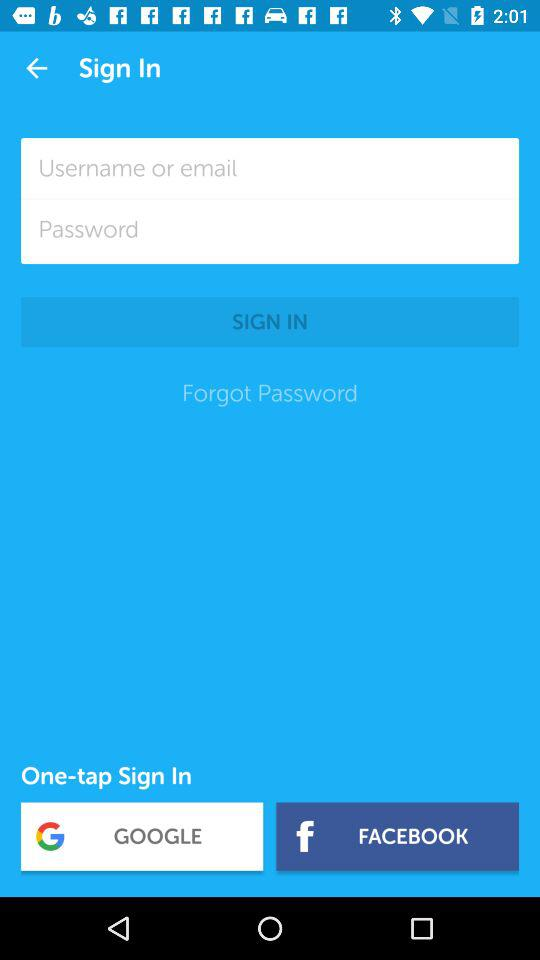How many text inputs are on the sign in screen?
Answer the question using a single word or phrase. 2 